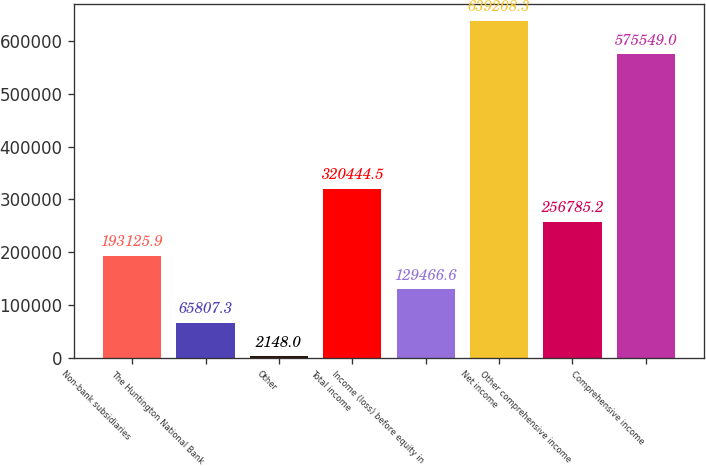<chart> <loc_0><loc_0><loc_500><loc_500><bar_chart><fcel>Non-bank subsidiaries<fcel>The Huntington National Bank<fcel>Other<fcel>Total income<fcel>Income (loss) before equity in<fcel>Net income<fcel>Other comprehensive income<fcel>Comprehensive income<nl><fcel>193126<fcel>65807.3<fcel>2148<fcel>320444<fcel>129467<fcel>639208<fcel>256785<fcel>575549<nl></chart> 